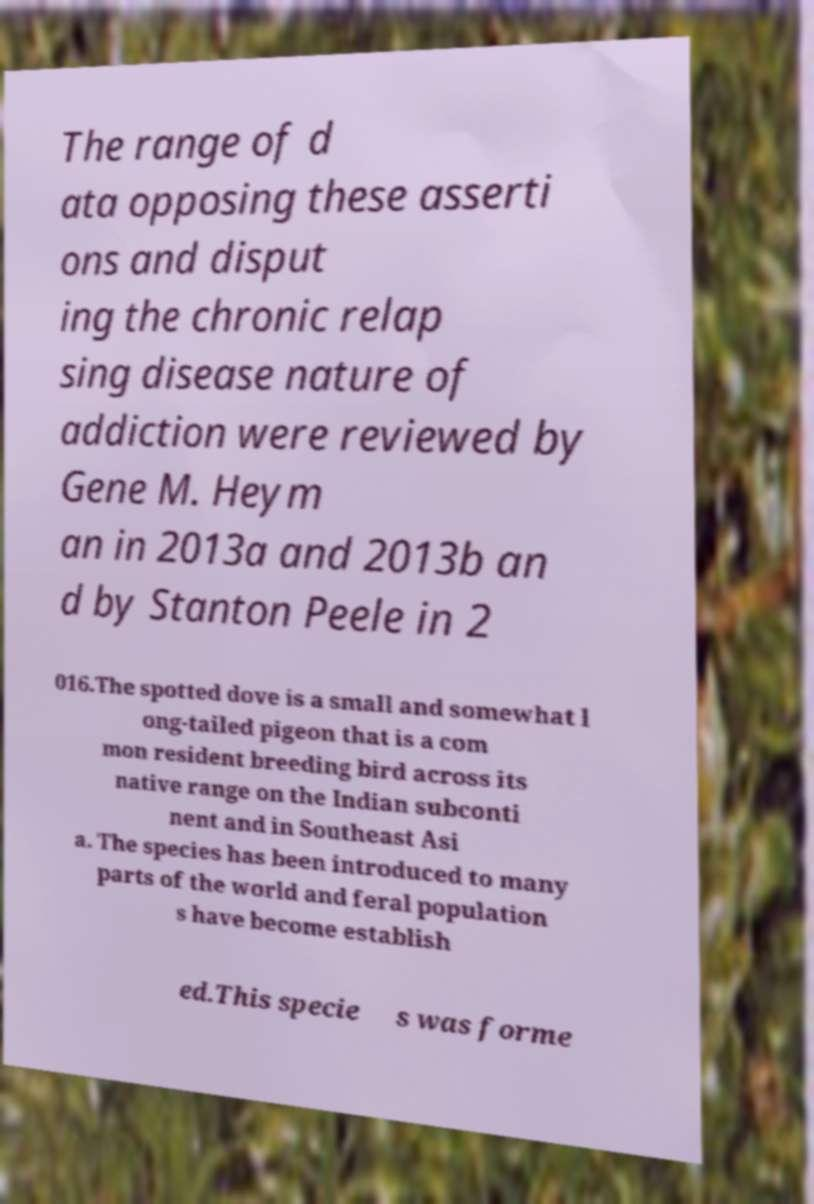Please read and relay the text visible in this image. What does it say? The range of d ata opposing these asserti ons and disput ing the chronic relap sing disease nature of addiction were reviewed by Gene M. Heym an in 2013a and 2013b an d by Stanton Peele in 2 016.The spotted dove is a small and somewhat l ong-tailed pigeon that is a com mon resident breeding bird across its native range on the Indian subconti nent and in Southeast Asi a. The species has been introduced to many parts of the world and feral population s have become establish ed.This specie s was forme 